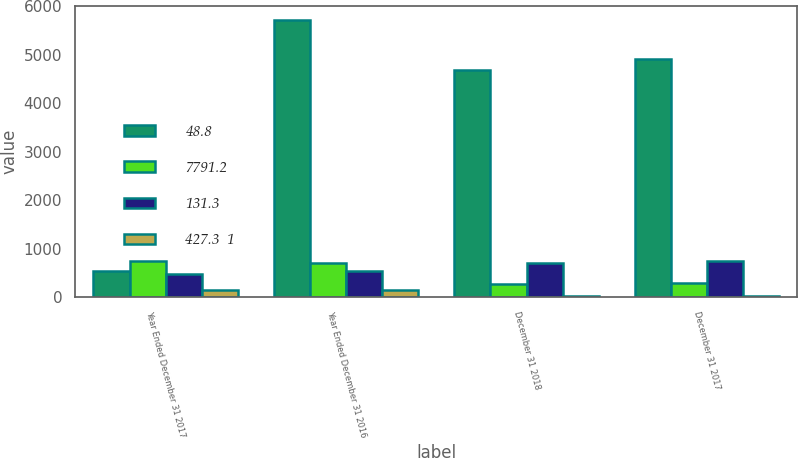Convert chart. <chart><loc_0><loc_0><loc_500><loc_500><stacked_bar_chart><ecel><fcel>Year Ended December 31 2017<fcel>Year Ended December 31 2016<fcel>December 31 2018<fcel>December 31 2017<nl><fcel>48.8<fcel>537.4<fcel>5730.3<fcel>4693.1<fcel>4910.5<nl><fcel>7791.2<fcel>742.8<fcel>706.5<fcel>261<fcel>297<nl><fcel>131.3<fcel>485.1<fcel>537.4<fcel>698.6<fcel>750.2<nl><fcel>427.3  1<fcel>140.4<fcel>154.5<fcel>22.5<fcel>20.5<nl></chart> 